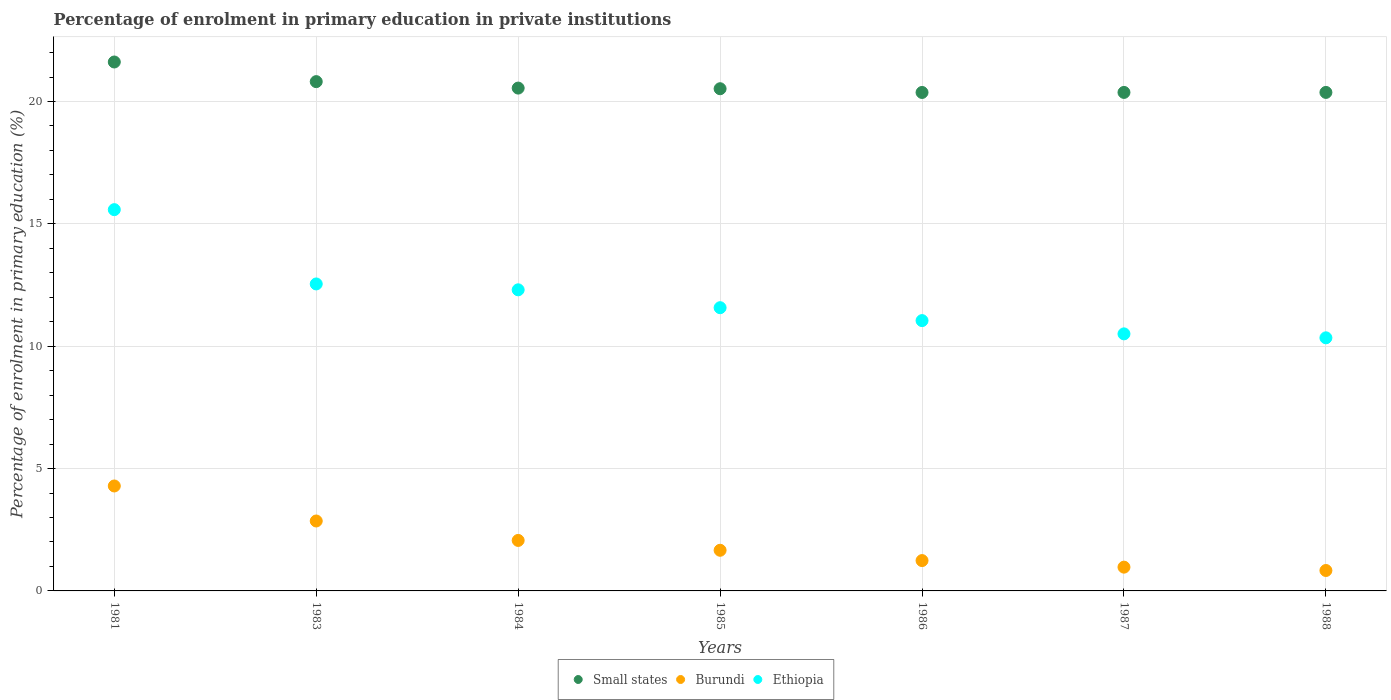How many different coloured dotlines are there?
Your answer should be very brief. 3. What is the percentage of enrolment in primary education in Small states in 1984?
Your answer should be compact. 20.55. Across all years, what is the maximum percentage of enrolment in primary education in Ethiopia?
Give a very brief answer. 15.58. Across all years, what is the minimum percentage of enrolment in primary education in Small states?
Your answer should be very brief. 20.37. What is the total percentage of enrolment in primary education in Small states in the graph?
Offer a very short reply. 144.62. What is the difference between the percentage of enrolment in primary education in Ethiopia in 1983 and that in 1988?
Your answer should be compact. 2.2. What is the difference between the percentage of enrolment in primary education in Small states in 1984 and the percentage of enrolment in primary education in Ethiopia in 1986?
Offer a terse response. 9.5. What is the average percentage of enrolment in primary education in Ethiopia per year?
Make the answer very short. 11.99. In the year 1981, what is the difference between the percentage of enrolment in primary education in Ethiopia and percentage of enrolment in primary education in Small states?
Offer a terse response. -6.03. In how many years, is the percentage of enrolment in primary education in Burundi greater than 17 %?
Your answer should be very brief. 0. What is the ratio of the percentage of enrolment in primary education in Burundi in 1983 to that in 1986?
Ensure brevity in your answer.  2.3. Is the percentage of enrolment in primary education in Ethiopia in 1983 less than that in 1984?
Provide a succinct answer. No. What is the difference between the highest and the second highest percentage of enrolment in primary education in Small states?
Provide a short and direct response. 0.8. What is the difference between the highest and the lowest percentage of enrolment in primary education in Burundi?
Offer a very short reply. 3.45. In how many years, is the percentage of enrolment in primary education in Small states greater than the average percentage of enrolment in primary education in Small states taken over all years?
Offer a terse response. 2. Is the percentage of enrolment in primary education in Ethiopia strictly greater than the percentage of enrolment in primary education in Small states over the years?
Make the answer very short. No. Does the graph contain any zero values?
Ensure brevity in your answer.  No. Does the graph contain grids?
Your answer should be very brief. Yes. How are the legend labels stacked?
Your response must be concise. Horizontal. What is the title of the graph?
Give a very brief answer. Percentage of enrolment in primary education in private institutions. What is the label or title of the Y-axis?
Provide a succinct answer. Percentage of enrolment in primary education (%). What is the Percentage of enrolment in primary education (%) of Small states in 1981?
Offer a very short reply. 21.62. What is the Percentage of enrolment in primary education (%) of Burundi in 1981?
Make the answer very short. 4.29. What is the Percentage of enrolment in primary education (%) in Ethiopia in 1981?
Keep it short and to the point. 15.58. What is the Percentage of enrolment in primary education (%) in Small states in 1983?
Make the answer very short. 20.81. What is the Percentage of enrolment in primary education (%) in Burundi in 1983?
Offer a terse response. 2.86. What is the Percentage of enrolment in primary education (%) in Ethiopia in 1983?
Give a very brief answer. 12.54. What is the Percentage of enrolment in primary education (%) of Small states in 1984?
Offer a very short reply. 20.55. What is the Percentage of enrolment in primary education (%) of Burundi in 1984?
Make the answer very short. 2.06. What is the Percentage of enrolment in primary education (%) of Ethiopia in 1984?
Your answer should be very brief. 12.31. What is the Percentage of enrolment in primary education (%) in Small states in 1985?
Your answer should be very brief. 20.52. What is the Percentage of enrolment in primary education (%) of Burundi in 1985?
Your response must be concise. 1.66. What is the Percentage of enrolment in primary education (%) of Ethiopia in 1985?
Make the answer very short. 11.57. What is the Percentage of enrolment in primary education (%) of Small states in 1986?
Offer a very short reply. 20.37. What is the Percentage of enrolment in primary education (%) of Burundi in 1986?
Provide a short and direct response. 1.24. What is the Percentage of enrolment in primary education (%) in Ethiopia in 1986?
Provide a succinct answer. 11.05. What is the Percentage of enrolment in primary education (%) of Small states in 1987?
Your answer should be very brief. 20.37. What is the Percentage of enrolment in primary education (%) of Burundi in 1987?
Your answer should be very brief. 0.97. What is the Percentage of enrolment in primary education (%) of Ethiopia in 1987?
Provide a short and direct response. 10.5. What is the Percentage of enrolment in primary education (%) in Small states in 1988?
Offer a terse response. 20.37. What is the Percentage of enrolment in primary education (%) in Burundi in 1988?
Offer a terse response. 0.83. What is the Percentage of enrolment in primary education (%) of Ethiopia in 1988?
Provide a succinct answer. 10.34. Across all years, what is the maximum Percentage of enrolment in primary education (%) of Small states?
Provide a succinct answer. 21.62. Across all years, what is the maximum Percentage of enrolment in primary education (%) of Burundi?
Give a very brief answer. 4.29. Across all years, what is the maximum Percentage of enrolment in primary education (%) in Ethiopia?
Keep it short and to the point. 15.58. Across all years, what is the minimum Percentage of enrolment in primary education (%) of Small states?
Provide a succinct answer. 20.37. Across all years, what is the minimum Percentage of enrolment in primary education (%) in Burundi?
Provide a succinct answer. 0.83. Across all years, what is the minimum Percentage of enrolment in primary education (%) in Ethiopia?
Provide a succinct answer. 10.34. What is the total Percentage of enrolment in primary education (%) of Small states in the graph?
Provide a short and direct response. 144.62. What is the total Percentage of enrolment in primary education (%) of Burundi in the graph?
Give a very brief answer. 13.92. What is the total Percentage of enrolment in primary education (%) of Ethiopia in the graph?
Provide a short and direct response. 83.9. What is the difference between the Percentage of enrolment in primary education (%) of Small states in 1981 and that in 1983?
Your answer should be compact. 0.8. What is the difference between the Percentage of enrolment in primary education (%) of Burundi in 1981 and that in 1983?
Offer a terse response. 1.43. What is the difference between the Percentage of enrolment in primary education (%) of Ethiopia in 1981 and that in 1983?
Your answer should be compact. 3.04. What is the difference between the Percentage of enrolment in primary education (%) in Small states in 1981 and that in 1984?
Give a very brief answer. 1.07. What is the difference between the Percentage of enrolment in primary education (%) in Burundi in 1981 and that in 1984?
Offer a very short reply. 2.23. What is the difference between the Percentage of enrolment in primary education (%) of Ethiopia in 1981 and that in 1984?
Your response must be concise. 3.28. What is the difference between the Percentage of enrolment in primary education (%) of Small states in 1981 and that in 1985?
Offer a very short reply. 1.09. What is the difference between the Percentage of enrolment in primary education (%) of Burundi in 1981 and that in 1985?
Give a very brief answer. 2.63. What is the difference between the Percentage of enrolment in primary education (%) of Ethiopia in 1981 and that in 1985?
Keep it short and to the point. 4.01. What is the difference between the Percentage of enrolment in primary education (%) in Small states in 1981 and that in 1986?
Provide a short and direct response. 1.24. What is the difference between the Percentage of enrolment in primary education (%) in Burundi in 1981 and that in 1986?
Provide a short and direct response. 3.05. What is the difference between the Percentage of enrolment in primary education (%) in Ethiopia in 1981 and that in 1986?
Provide a short and direct response. 4.53. What is the difference between the Percentage of enrolment in primary education (%) of Small states in 1981 and that in 1987?
Give a very brief answer. 1.24. What is the difference between the Percentage of enrolment in primary education (%) in Burundi in 1981 and that in 1987?
Make the answer very short. 3.32. What is the difference between the Percentage of enrolment in primary education (%) in Ethiopia in 1981 and that in 1987?
Your answer should be very brief. 5.08. What is the difference between the Percentage of enrolment in primary education (%) of Small states in 1981 and that in 1988?
Offer a terse response. 1.24. What is the difference between the Percentage of enrolment in primary education (%) of Burundi in 1981 and that in 1988?
Offer a terse response. 3.45. What is the difference between the Percentage of enrolment in primary education (%) of Ethiopia in 1981 and that in 1988?
Provide a succinct answer. 5.24. What is the difference between the Percentage of enrolment in primary education (%) in Small states in 1983 and that in 1984?
Your answer should be very brief. 0.26. What is the difference between the Percentage of enrolment in primary education (%) of Burundi in 1983 and that in 1984?
Your answer should be compact. 0.79. What is the difference between the Percentage of enrolment in primary education (%) of Ethiopia in 1983 and that in 1984?
Provide a succinct answer. 0.24. What is the difference between the Percentage of enrolment in primary education (%) in Small states in 1983 and that in 1985?
Make the answer very short. 0.29. What is the difference between the Percentage of enrolment in primary education (%) in Burundi in 1983 and that in 1985?
Ensure brevity in your answer.  1.2. What is the difference between the Percentage of enrolment in primary education (%) of Ethiopia in 1983 and that in 1985?
Your answer should be very brief. 0.97. What is the difference between the Percentage of enrolment in primary education (%) of Small states in 1983 and that in 1986?
Your answer should be very brief. 0.44. What is the difference between the Percentage of enrolment in primary education (%) of Burundi in 1983 and that in 1986?
Give a very brief answer. 1.62. What is the difference between the Percentage of enrolment in primary education (%) of Ethiopia in 1983 and that in 1986?
Your response must be concise. 1.5. What is the difference between the Percentage of enrolment in primary education (%) in Small states in 1983 and that in 1987?
Provide a succinct answer. 0.44. What is the difference between the Percentage of enrolment in primary education (%) of Burundi in 1983 and that in 1987?
Give a very brief answer. 1.89. What is the difference between the Percentage of enrolment in primary education (%) in Ethiopia in 1983 and that in 1987?
Your answer should be compact. 2.04. What is the difference between the Percentage of enrolment in primary education (%) of Small states in 1983 and that in 1988?
Ensure brevity in your answer.  0.44. What is the difference between the Percentage of enrolment in primary education (%) in Burundi in 1983 and that in 1988?
Ensure brevity in your answer.  2.02. What is the difference between the Percentage of enrolment in primary education (%) in Ethiopia in 1983 and that in 1988?
Make the answer very short. 2.2. What is the difference between the Percentage of enrolment in primary education (%) of Small states in 1984 and that in 1985?
Make the answer very short. 0.03. What is the difference between the Percentage of enrolment in primary education (%) of Burundi in 1984 and that in 1985?
Ensure brevity in your answer.  0.4. What is the difference between the Percentage of enrolment in primary education (%) in Ethiopia in 1984 and that in 1985?
Offer a terse response. 0.73. What is the difference between the Percentage of enrolment in primary education (%) in Small states in 1984 and that in 1986?
Your answer should be compact. 0.18. What is the difference between the Percentage of enrolment in primary education (%) in Burundi in 1984 and that in 1986?
Keep it short and to the point. 0.82. What is the difference between the Percentage of enrolment in primary education (%) of Ethiopia in 1984 and that in 1986?
Ensure brevity in your answer.  1.26. What is the difference between the Percentage of enrolment in primary education (%) in Small states in 1984 and that in 1987?
Offer a terse response. 0.18. What is the difference between the Percentage of enrolment in primary education (%) in Burundi in 1984 and that in 1987?
Offer a terse response. 1.09. What is the difference between the Percentage of enrolment in primary education (%) in Ethiopia in 1984 and that in 1987?
Offer a very short reply. 1.8. What is the difference between the Percentage of enrolment in primary education (%) in Small states in 1984 and that in 1988?
Keep it short and to the point. 0.18. What is the difference between the Percentage of enrolment in primary education (%) of Burundi in 1984 and that in 1988?
Provide a short and direct response. 1.23. What is the difference between the Percentage of enrolment in primary education (%) of Ethiopia in 1984 and that in 1988?
Ensure brevity in your answer.  1.96. What is the difference between the Percentage of enrolment in primary education (%) in Small states in 1985 and that in 1986?
Provide a succinct answer. 0.15. What is the difference between the Percentage of enrolment in primary education (%) in Burundi in 1985 and that in 1986?
Offer a terse response. 0.42. What is the difference between the Percentage of enrolment in primary education (%) in Ethiopia in 1985 and that in 1986?
Offer a terse response. 0.53. What is the difference between the Percentage of enrolment in primary education (%) of Small states in 1985 and that in 1987?
Your answer should be compact. 0.15. What is the difference between the Percentage of enrolment in primary education (%) of Burundi in 1985 and that in 1987?
Give a very brief answer. 0.69. What is the difference between the Percentage of enrolment in primary education (%) in Ethiopia in 1985 and that in 1987?
Offer a terse response. 1.07. What is the difference between the Percentage of enrolment in primary education (%) in Small states in 1985 and that in 1988?
Make the answer very short. 0.15. What is the difference between the Percentage of enrolment in primary education (%) of Burundi in 1985 and that in 1988?
Provide a short and direct response. 0.83. What is the difference between the Percentage of enrolment in primary education (%) in Ethiopia in 1985 and that in 1988?
Your answer should be very brief. 1.23. What is the difference between the Percentage of enrolment in primary education (%) in Small states in 1986 and that in 1987?
Your response must be concise. -0. What is the difference between the Percentage of enrolment in primary education (%) of Burundi in 1986 and that in 1987?
Provide a short and direct response. 0.27. What is the difference between the Percentage of enrolment in primary education (%) in Ethiopia in 1986 and that in 1987?
Your answer should be very brief. 0.54. What is the difference between the Percentage of enrolment in primary education (%) in Small states in 1986 and that in 1988?
Your answer should be compact. -0. What is the difference between the Percentage of enrolment in primary education (%) in Burundi in 1986 and that in 1988?
Provide a short and direct response. 0.41. What is the difference between the Percentage of enrolment in primary education (%) of Ethiopia in 1986 and that in 1988?
Offer a very short reply. 0.7. What is the difference between the Percentage of enrolment in primary education (%) of Small states in 1987 and that in 1988?
Provide a succinct answer. -0. What is the difference between the Percentage of enrolment in primary education (%) in Burundi in 1987 and that in 1988?
Provide a succinct answer. 0.14. What is the difference between the Percentage of enrolment in primary education (%) in Ethiopia in 1987 and that in 1988?
Offer a very short reply. 0.16. What is the difference between the Percentage of enrolment in primary education (%) of Small states in 1981 and the Percentage of enrolment in primary education (%) of Burundi in 1983?
Ensure brevity in your answer.  18.76. What is the difference between the Percentage of enrolment in primary education (%) of Small states in 1981 and the Percentage of enrolment in primary education (%) of Ethiopia in 1983?
Make the answer very short. 9.07. What is the difference between the Percentage of enrolment in primary education (%) in Burundi in 1981 and the Percentage of enrolment in primary education (%) in Ethiopia in 1983?
Give a very brief answer. -8.26. What is the difference between the Percentage of enrolment in primary education (%) of Small states in 1981 and the Percentage of enrolment in primary education (%) of Burundi in 1984?
Your answer should be compact. 19.55. What is the difference between the Percentage of enrolment in primary education (%) of Small states in 1981 and the Percentage of enrolment in primary education (%) of Ethiopia in 1984?
Give a very brief answer. 9.31. What is the difference between the Percentage of enrolment in primary education (%) of Burundi in 1981 and the Percentage of enrolment in primary education (%) of Ethiopia in 1984?
Make the answer very short. -8.02. What is the difference between the Percentage of enrolment in primary education (%) in Small states in 1981 and the Percentage of enrolment in primary education (%) in Burundi in 1985?
Offer a very short reply. 19.95. What is the difference between the Percentage of enrolment in primary education (%) in Small states in 1981 and the Percentage of enrolment in primary education (%) in Ethiopia in 1985?
Your answer should be compact. 10.04. What is the difference between the Percentage of enrolment in primary education (%) in Burundi in 1981 and the Percentage of enrolment in primary education (%) in Ethiopia in 1985?
Provide a succinct answer. -7.29. What is the difference between the Percentage of enrolment in primary education (%) of Small states in 1981 and the Percentage of enrolment in primary education (%) of Burundi in 1986?
Make the answer very short. 20.38. What is the difference between the Percentage of enrolment in primary education (%) of Small states in 1981 and the Percentage of enrolment in primary education (%) of Ethiopia in 1986?
Your answer should be very brief. 10.57. What is the difference between the Percentage of enrolment in primary education (%) in Burundi in 1981 and the Percentage of enrolment in primary education (%) in Ethiopia in 1986?
Provide a short and direct response. -6.76. What is the difference between the Percentage of enrolment in primary education (%) of Small states in 1981 and the Percentage of enrolment in primary education (%) of Burundi in 1987?
Offer a very short reply. 20.64. What is the difference between the Percentage of enrolment in primary education (%) in Small states in 1981 and the Percentage of enrolment in primary education (%) in Ethiopia in 1987?
Make the answer very short. 11.11. What is the difference between the Percentage of enrolment in primary education (%) of Burundi in 1981 and the Percentage of enrolment in primary education (%) of Ethiopia in 1987?
Your response must be concise. -6.22. What is the difference between the Percentage of enrolment in primary education (%) in Small states in 1981 and the Percentage of enrolment in primary education (%) in Burundi in 1988?
Make the answer very short. 20.78. What is the difference between the Percentage of enrolment in primary education (%) in Small states in 1981 and the Percentage of enrolment in primary education (%) in Ethiopia in 1988?
Provide a short and direct response. 11.27. What is the difference between the Percentage of enrolment in primary education (%) in Burundi in 1981 and the Percentage of enrolment in primary education (%) in Ethiopia in 1988?
Ensure brevity in your answer.  -6.05. What is the difference between the Percentage of enrolment in primary education (%) of Small states in 1983 and the Percentage of enrolment in primary education (%) of Burundi in 1984?
Offer a very short reply. 18.75. What is the difference between the Percentage of enrolment in primary education (%) of Small states in 1983 and the Percentage of enrolment in primary education (%) of Ethiopia in 1984?
Provide a succinct answer. 8.51. What is the difference between the Percentage of enrolment in primary education (%) of Burundi in 1983 and the Percentage of enrolment in primary education (%) of Ethiopia in 1984?
Your answer should be compact. -9.45. What is the difference between the Percentage of enrolment in primary education (%) of Small states in 1983 and the Percentage of enrolment in primary education (%) of Burundi in 1985?
Give a very brief answer. 19.15. What is the difference between the Percentage of enrolment in primary education (%) in Small states in 1983 and the Percentage of enrolment in primary education (%) in Ethiopia in 1985?
Your answer should be very brief. 9.24. What is the difference between the Percentage of enrolment in primary education (%) in Burundi in 1983 and the Percentage of enrolment in primary education (%) in Ethiopia in 1985?
Give a very brief answer. -8.72. What is the difference between the Percentage of enrolment in primary education (%) in Small states in 1983 and the Percentage of enrolment in primary education (%) in Burundi in 1986?
Your response must be concise. 19.57. What is the difference between the Percentage of enrolment in primary education (%) in Small states in 1983 and the Percentage of enrolment in primary education (%) in Ethiopia in 1986?
Your answer should be compact. 9.77. What is the difference between the Percentage of enrolment in primary education (%) in Burundi in 1983 and the Percentage of enrolment in primary education (%) in Ethiopia in 1986?
Give a very brief answer. -8.19. What is the difference between the Percentage of enrolment in primary education (%) of Small states in 1983 and the Percentage of enrolment in primary education (%) of Burundi in 1987?
Keep it short and to the point. 19.84. What is the difference between the Percentage of enrolment in primary education (%) of Small states in 1983 and the Percentage of enrolment in primary education (%) of Ethiopia in 1987?
Give a very brief answer. 10.31. What is the difference between the Percentage of enrolment in primary education (%) in Burundi in 1983 and the Percentage of enrolment in primary education (%) in Ethiopia in 1987?
Offer a terse response. -7.65. What is the difference between the Percentage of enrolment in primary education (%) in Small states in 1983 and the Percentage of enrolment in primary education (%) in Burundi in 1988?
Your response must be concise. 19.98. What is the difference between the Percentage of enrolment in primary education (%) in Small states in 1983 and the Percentage of enrolment in primary education (%) in Ethiopia in 1988?
Provide a succinct answer. 10.47. What is the difference between the Percentage of enrolment in primary education (%) in Burundi in 1983 and the Percentage of enrolment in primary education (%) in Ethiopia in 1988?
Your answer should be compact. -7.49. What is the difference between the Percentage of enrolment in primary education (%) of Small states in 1984 and the Percentage of enrolment in primary education (%) of Burundi in 1985?
Your answer should be compact. 18.89. What is the difference between the Percentage of enrolment in primary education (%) in Small states in 1984 and the Percentage of enrolment in primary education (%) in Ethiopia in 1985?
Keep it short and to the point. 8.97. What is the difference between the Percentage of enrolment in primary education (%) in Burundi in 1984 and the Percentage of enrolment in primary education (%) in Ethiopia in 1985?
Provide a succinct answer. -9.51. What is the difference between the Percentage of enrolment in primary education (%) of Small states in 1984 and the Percentage of enrolment in primary education (%) of Burundi in 1986?
Provide a short and direct response. 19.31. What is the difference between the Percentage of enrolment in primary education (%) in Small states in 1984 and the Percentage of enrolment in primary education (%) in Ethiopia in 1986?
Keep it short and to the point. 9.5. What is the difference between the Percentage of enrolment in primary education (%) in Burundi in 1984 and the Percentage of enrolment in primary education (%) in Ethiopia in 1986?
Keep it short and to the point. -8.98. What is the difference between the Percentage of enrolment in primary education (%) of Small states in 1984 and the Percentage of enrolment in primary education (%) of Burundi in 1987?
Your response must be concise. 19.58. What is the difference between the Percentage of enrolment in primary education (%) in Small states in 1984 and the Percentage of enrolment in primary education (%) in Ethiopia in 1987?
Offer a terse response. 10.04. What is the difference between the Percentage of enrolment in primary education (%) in Burundi in 1984 and the Percentage of enrolment in primary education (%) in Ethiopia in 1987?
Offer a very short reply. -8.44. What is the difference between the Percentage of enrolment in primary education (%) of Small states in 1984 and the Percentage of enrolment in primary education (%) of Burundi in 1988?
Your response must be concise. 19.71. What is the difference between the Percentage of enrolment in primary education (%) of Small states in 1984 and the Percentage of enrolment in primary education (%) of Ethiopia in 1988?
Offer a terse response. 10.21. What is the difference between the Percentage of enrolment in primary education (%) of Burundi in 1984 and the Percentage of enrolment in primary education (%) of Ethiopia in 1988?
Ensure brevity in your answer.  -8.28. What is the difference between the Percentage of enrolment in primary education (%) of Small states in 1985 and the Percentage of enrolment in primary education (%) of Burundi in 1986?
Your answer should be compact. 19.28. What is the difference between the Percentage of enrolment in primary education (%) in Small states in 1985 and the Percentage of enrolment in primary education (%) in Ethiopia in 1986?
Make the answer very short. 9.48. What is the difference between the Percentage of enrolment in primary education (%) in Burundi in 1985 and the Percentage of enrolment in primary education (%) in Ethiopia in 1986?
Keep it short and to the point. -9.39. What is the difference between the Percentage of enrolment in primary education (%) in Small states in 1985 and the Percentage of enrolment in primary education (%) in Burundi in 1987?
Ensure brevity in your answer.  19.55. What is the difference between the Percentage of enrolment in primary education (%) of Small states in 1985 and the Percentage of enrolment in primary education (%) of Ethiopia in 1987?
Give a very brief answer. 10.02. What is the difference between the Percentage of enrolment in primary education (%) in Burundi in 1985 and the Percentage of enrolment in primary education (%) in Ethiopia in 1987?
Your response must be concise. -8.84. What is the difference between the Percentage of enrolment in primary education (%) in Small states in 1985 and the Percentage of enrolment in primary education (%) in Burundi in 1988?
Give a very brief answer. 19.69. What is the difference between the Percentage of enrolment in primary education (%) in Small states in 1985 and the Percentage of enrolment in primary education (%) in Ethiopia in 1988?
Your answer should be compact. 10.18. What is the difference between the Percentage of enrolment in primary education (%) in Burundi in 1985 and the Percentage of enrolment in primary education (%) in Ethiopia in 1988?
Your response must be concise. -8.68. What is the difference between the Percentage of enrolment in primary education (%) of Small states in 1986 and the Percentage of enrolment in primary education (%) of Burundi in 1987?
Provide a succinct answer. 19.4. What is the difference between the Percentage of enrolment in primary education (%) in Small states in 1986 and the Percentage of enrolment in primary education (%) in Ethiopia in 1987?
Provide a succinct answer. 9.87. What is the difference between the Percentage of enrolment in primary education (%) in Burundi in 1986 and the Percentage of enrolment in primary education (%) in Ethiopia in 1987?
Your answer should be compact. -9.26. What is the difference between the Percentage of enrolment in primary education (%) of Small states in 1986 and the Percentage of enrolment in primary education (%) of Burundi in 1988?
Offer a terse response. 19.54. What is the difference between the Percentage of enrolment in primary education (%) in Small states in 1986 and the Percentage of enrolment in primary education (%) in Ethiopia in 1988?
Offer a terse response. 10.03. What is the difference between the Percentage of enrolment in primary education (%) in Burundi in 1986 and the Percentage of enrolment in primary education (%) in Ethiopia in 1988?
Keep it short and to the point. -9.1. What is the difference between the Percentage of enrolment in primary education (%) in Small states in 1987 and the Percentage of enrolment in primary education (%) in Burundi in 1988?
Keep it short and to the point. 19.54. What is the difference between the Percentage of enrolment in primary education (%) of Small states in 1987 and the Percentage of enrolment in primary education (%) of Ethiopia in 1988?
Your response must be concise. 10.03. What is the difference between the Percentage of enrolment in primary education (%) of Burundi in 1987 and the Percentage of enrolment in primary education (%) of Ethiopia in 1988?
Provide a short and direct response. -9.37. What is the average Percentage of enrolment in primary education (%) in Small states per year?
Your response must be concise. 20.66. What is the average Percentage of enrolment in primary education (%) of Burundi per year?
Make the answer very short. 1.99. What is the average Percentage of enrolment in primary education (%) in Ethiopia per year?
Make the answer very short. 11.99. In the year 1981, what is the difference between the Percentage of enrolment in primary education (%) in Small states and Percentage of enrolment in primary education (%) in Burundi?
Provide a short and direct response. 17.33. In the year 1981, what is the difference between the Percentage of enrolment in primary education (%) in Small states and Percentage of enrolment in primary education (%) in Ethiopia?
Make the answer very short. 6.03. In the year 1981, what is the difference between the Percentage of enrolment in primary education (%) of Burundi and Percentage of enrolment in primary education (%) of Ethiopia?
Ensure brevity in your answer.  -11.29. In the year 1983, what is the difference between the Percentage of enrolment in primary education (%) in Small states and Percentage of enrolment in primary education (%) in Burundi?
Keep it short and to the point. 17.96. In the year 1983, what is the difference between the Percentage of enrolment in primary education (%) of Small states and Percentage of enrolment in primary education (%) of Ethiopia?
Your response must be concise. 8.27. In the year 1983, what is the difference between the Percentage of enrolment in primary education (%) in Burundi and Percentage of enrolment in primary education (%) in Ethiopia?
Ensure brevity in your answer.  -9.69. In the year 1984, what is the difference between the Percentage of enrolment in primary education (%) of Small states and Percentage of enrolment in primary education (%) of Burundi?
Give a very brief answer. 18.49. In the year 1984, what is the difference between the Percentage of enrolment in primary education (%) in Small states and Percentage of enrolment in primary education (%) in Ethiopia?
Give a very brief answer. 8.24. In the year 1984, what is the difference between the Percentage of enrolment in primary education (%) of Burundi and Percentage of enrolment in primary education (%) of Ethiopia?
Your answer should be very brief. -10.24. In the year 1985, what is the difference between the Percentage of enrolment in primary education (%) of Small states and Percentage of enrolment in primary education (%) of Burundi?
Offer a very short reply. 18.86. In the year 1985, what is the difference between the Percentage of enrolment in primary education (%) in Small states and Percentage of enrolment in primary education (%) in Ethiopia?
Provide a succinct answer. 8.95. In the year 1985, what is the difference between the Percentage of enrolment in primary education (%) of Burundi and Percentage of enrolment in primary education (%) of Ethiopia?
Provide a short and direct response. -9.91. In the year 1986, what is the difference between the Percentage of enrolment in primary education (%) of Small states and Percentage of enrolment in primary education (%) of Burundi?
Keep it short and to the point. 19.13. In the year 1986, what is the difference between the Percentage of enrolment in primary education (%) of Small states and Percentage of enrolment in primary education (%) of Ethiopia?
Provide a short and direct response. 9.32. In the year 1986, what is the difference between the Percentage of enrolment in primary education (%) in Burundi and Percentage of enrolment in primary education (%) in Ethiopia?
Make the answer very short. -9.81. In the year 1987, what is the difference between the Percentage of enrolment in primary education (%) in Small states and Percentage of enrolment in primary education (%) in Burundi?
Your answer should be very brief. 19.4. In the year 1987, what is the difference between the Percentage of enrolment in primary education (%) in Small states and Percentage of enrolment in primary education (%) in Ethiopia?
Offer a terse response. 9.87. In the year 1987, what is the difference between the Percentage of enrolment in primary education (%) of Burundi and Percentage of enrolment in primary education (%) of Ethiopia?
Offer a terse response. -9.53. In the year 1988, what is the difference between the Percentage of enrolment in primary education (%) in Small states and Percentage of enrolment in primary education (%) in Burundi?
Your response must be concise. 19.54. In the year 1988, what is the difference between the Percentage of enrolment in primary education (%) in Small states and Percentage of enrolment in primary education (%) in Ethiopia?
Offer a very short reply. 10.03. In the year 1988, what is the difference between the Percentage of enrolment in primary education (%) of Burundi and Percentage of enrolment in primary education (%) of Ethiopia?
Your answer should be very brief. -9.51. What is the ratio of the Percentage of enrolment in primary education (%) in Small states in 1981 to that in 1983?
Provide a succinct answer. 1.04. What is the ratio of the Percentage of enrolment in primary education (%) of Burundi in 1981 to that in 1983?
Provide a succinct answer. 1.5. What is the ratio of the Percentage of enrolment in primary education (%) in Ethiopia in 1981 to that in 1983?
Offer a terse response. 1.24. What is the ratio of the Percentage of enrolment in primary education (%) of Small states in 1981 to that in 1984?
Offer a terse response. 1.05. What is the ratio of the Percentage of enrolment in primary education (%) of Burundi in 1981 to that in 1984?
Provide a short and direct response. 2.08. What is the ratio of the Percentage of enrolment in primary education (%) of Ethiopia in 1981 to that in 1984?
Provide a succinct answer. 1.27. What is the ratio of the Percentage of enrolment in primary education (%) in Small states in 1981 to that in 1985?
Provide a succinct answer. 1.05. What is the ratio of the Percentage of enrolment in primary education (%) in Burundi in 1981 to that in 1985?
Provide a succinct answer. 2.58. What is the ratio of the Percentage of enrolment in primary education (%) in Ethiopia in 1981 to that in 1985?
Ensure brevity in your answer.  1.35. What is the ratio of the Percentage of enrolment in primary education (%) in Small states in 1981 to that in 1986?
Ensure brevity in your answer.  1.06. What is the ratio of the Percentage of enrolment in primary education (%) in Burundi in 1981 to that in 1986?
Your response must be concise. 3.46. What is the ratio of the Percentage of enrolment in primary education (%) in Ethiopia in 1981 to that in 1986?
Offer a very short reply. 1.41. What is the ratio of the Percentage of enrolment in primary education (%) in Small states in 1981 to that in 1987?
Offer a very short reply. 1.06. What is the ratio of the Percentage of enrolment in primary education (%) in Burundi in 1981 to that in 1987?
Provide a succinct answer. 4.41. What is the ratio of the Percentage of enrolment in primary education (%) in Ethiopia in 1981 to that in 1987?
Your answer should be compact. 1.48. What is the ratio of the Percentage of enrolment in primary education (%) of Small states in 1981 to that in 1988?
Your answer should be very brief. 1.06. What is the ratio of the Percentage of enrolment in primary education (%) in Burundi in 1981 to that in 1988?
Keep it short and to the point. 5.14. What is the ratio of the Percentage of enrolment in primary education (%) in Ethiopia in 1981 to that in 1988?
Make the answer very short. 1.51. What is the ratio of the Percentage of enrolment in primary education (%) of Small states in 1983 to that in 1984?
Your answer should be very brief. 1.01. What is the ratio of the Percentage of enrolment in primary education (%) of Burundi in 1983 to that in 1984?
Your answer should be compact. 1.39. What is the ratio of the Percentage of enrolment in primary education (%) in Ethiopia in 1983 to that in 1984?
Give a very brief answer. 1.02. What is the ratio of the Percentage of enrolment in primary education (%) of Small states in 1983 to that in 1985?
Your answer should be very brief. 1.01. What is the ratio of the Percentage of enrolment in primary education (%) of Burundi in 1983 to that in 1985?
Your response must be concise. 1.72. What is the ratio of the Percentage of enrolment in primary education (%) of Ethiopia in 1983 to that in 1985?
Make the answer very short. 1.08. What is the ratio of the Percentage of enrolment in primary education (%) of Small states in 1983 to that in 1986?
Make the answer very short. 1.02. What is the ratio of the Percentage of enrolment in primary education (%) of Burundi in 1983 to that in 1986?
Give a very brief answer. 2.3. What is the ratio of the Percentage of enrolment in primary education (%) in Ethiopia in 1983 to that in 1986?
Keep it short and to the point. 1.14. What is the ratio of the Percentage of enrolment in primary education (%) in Small states in 1983 to that in 1987?
Provide a succinct answer. 1.02. What is the ratio of the Percentage of enrolment in primary education (%) in Burundi in 1983 to that in 1987?
Provide a succinct answer. 2.94. What is the ratio of the Percentage of enrolment in primary education (%) in Ethiopia in 1983 to that in 1987?
Make the answer very short. 1.19. What is the ratio of the Percentage of enrolment in primary education (%) of Small states in 1983 to that in 1988?
Your response must be concise. 1.02. What is the ratio of the Percentage of enrolment in primary education (%) in Burundi in 1983 to that in 1988?
Provide a succinct answer. 3.42. What is the ratio of the Percentage of enrolment in primary education (%) in Ethiopia in 1983 to that in 1988?
Provide a short and direct response. 1.21. What is the ratio of the Percentage of enrolment in primary education (%) in Burundi in 1984 to that in 1985?
Make the answer very short. 1.24. What is the ratio of the Percentage of enrolment in primary education (%) of Ethiopia in 1984 to that in 1985?
Your answer should be compact. 1.06. What is the ratio of the Percentage of enrolment in primary education (%) of Small states in 1984 to that in 1986?
Your answer should be compact. 1.01. What is the ratio of the Percentage of enrolment in primary education (%) of Burundi in 1984 to that in 1986?
Keep it short and to the point. 1.66. What is the ratio of the Percentage of enrolment in primary education (%) of Ethiopia in 1984 to that in 1986?
Keep it short and to the point. 1.11. What is the ratio of the Percentage of enrolment in primary education (%) of Small states in 1984 to that in 1987?
Provide a short and direct response. 1.01. What is the ratio of the Percentage of enrolment in primary education (%) in Burundi in 1984 to that in 1987?
Your answer should be very brief. 2.12. What is the ratio of the Percentage of enrolment in primary education (%) in Ethiopia in 1984 to that in 1987?
Your answer should be very brief. 1.17. What is the ratio of the Percentage of enrolment in primary education (%) of Small states in 1984 to that in 1988?
Your answer should be very brief. 1.01. What is the ratio of the Percentage of enrolment in primary education (%) of Burundi in 1984 to that in 1988?
Offer a very short reply. 2.47. What is the ratio of the Percentage of enrolment in primary education (%) of Ethiopia in 1984 to that in 1988?
Make the answer very short. 1.19. What is the ratio of the Percentage of enrolment in primary education (%) of Small states in 1985 to that in 1986?
Provide a succinct answer. 1.01. What is the ratio of the Percentage of enrolment in primary education (%) of Burundi in 1985 to that in 1986?
Your answer should be compact. 1.34. What is the ratio of the Percentage of enrolment in primary education (%) in Ethiopia in 1985 to that in 1986?
Keep it short and to the point. 1.05. What is the ratio of the Percentage of enrolment in primary education (%) of Small states in 1985 to that in 1987?
Provide a succinct answer. 1.01. What is the ratio of the Percentage of enrolment in primary education (%) of Burundi in 1985 to that in 1987?
Ensure brevity in your answer.  1.71. What is the ratio of the Percentage of enrolment in primary education (%) of Ethiopia in 1985 to that in 1987?
Ensure brevity in your answer.  1.1. What is the ratio of the Percentage of enrolment in primary education (%) of Small states in 1985 to that in 1988?
Make the answer very short. 1.01. What is the ratio of the Percentage of enrolment in primary education (%) in Burundi in 1985 to that in 1988?
Your answer should be compact. 1.99. What is the ratio of the Percentage of enrolment in primary education (%) of Ethiopia in 1985 to that in 1988?
Keep it short and to the point. 1.12. What is the ratio of the Percentage of enrolment in primary education (%) of Burundi in 1986 to that in 1987?
Give a very brief answer. 1.28. What is the ratio of the Percentage of enrolment in primary education (%) in Ethiopia in 1986 to that in 1987?
Ensure brevity in your answer.  1.05. What is the ratio of the Percentage of enrolment in primary education (%) of Burundi in 1986 to that in 1988?
Give a very brief answer. 1.49. What is the ratio of the Percentage of enrolment in primary education (%) of Ethiopia in 1986 to that in 1988?
Offer a terse response. 1.07. What is the ratio of the Percentage of enrolment in primary education (%) in Burundi in 1987 to that in 1988?
Provide a short and direct response. 1.16. What is the ratio of the Percentage of enrolment in primary education (%) of Ethiopia in 1987 to that in 1988?
Your answer should be very brief. 1.02. What is the difference between the highest and the second highest Percentage of enrolment in primary education (%) in Small states?
Give a very brief answer. 0.8. What is the difference between the highest and the second highest Percentage of enrolment in primary education (%) of Burundi?
Keep it short and to the point. 1.43. What is the difference between the highest and the second highest Percentage of enrolment in primary education (%) in Ethiopia?
Offer a very short reply. 3.04. What is the difference between the highest and the lowest Percentage of enrolment in primary education (%) of Small states?
Offer a terse response. 1.24. What is the difference between the highest and the lowest Percentage of enrolment in primary education (%) in Burundi?
Ensure brevity in your answer.  3.45. What is the difference between the highest and the lowest Percentage of enrolment in primary education (%) in Ethiopia?
Make the answer very short. 5.24. 